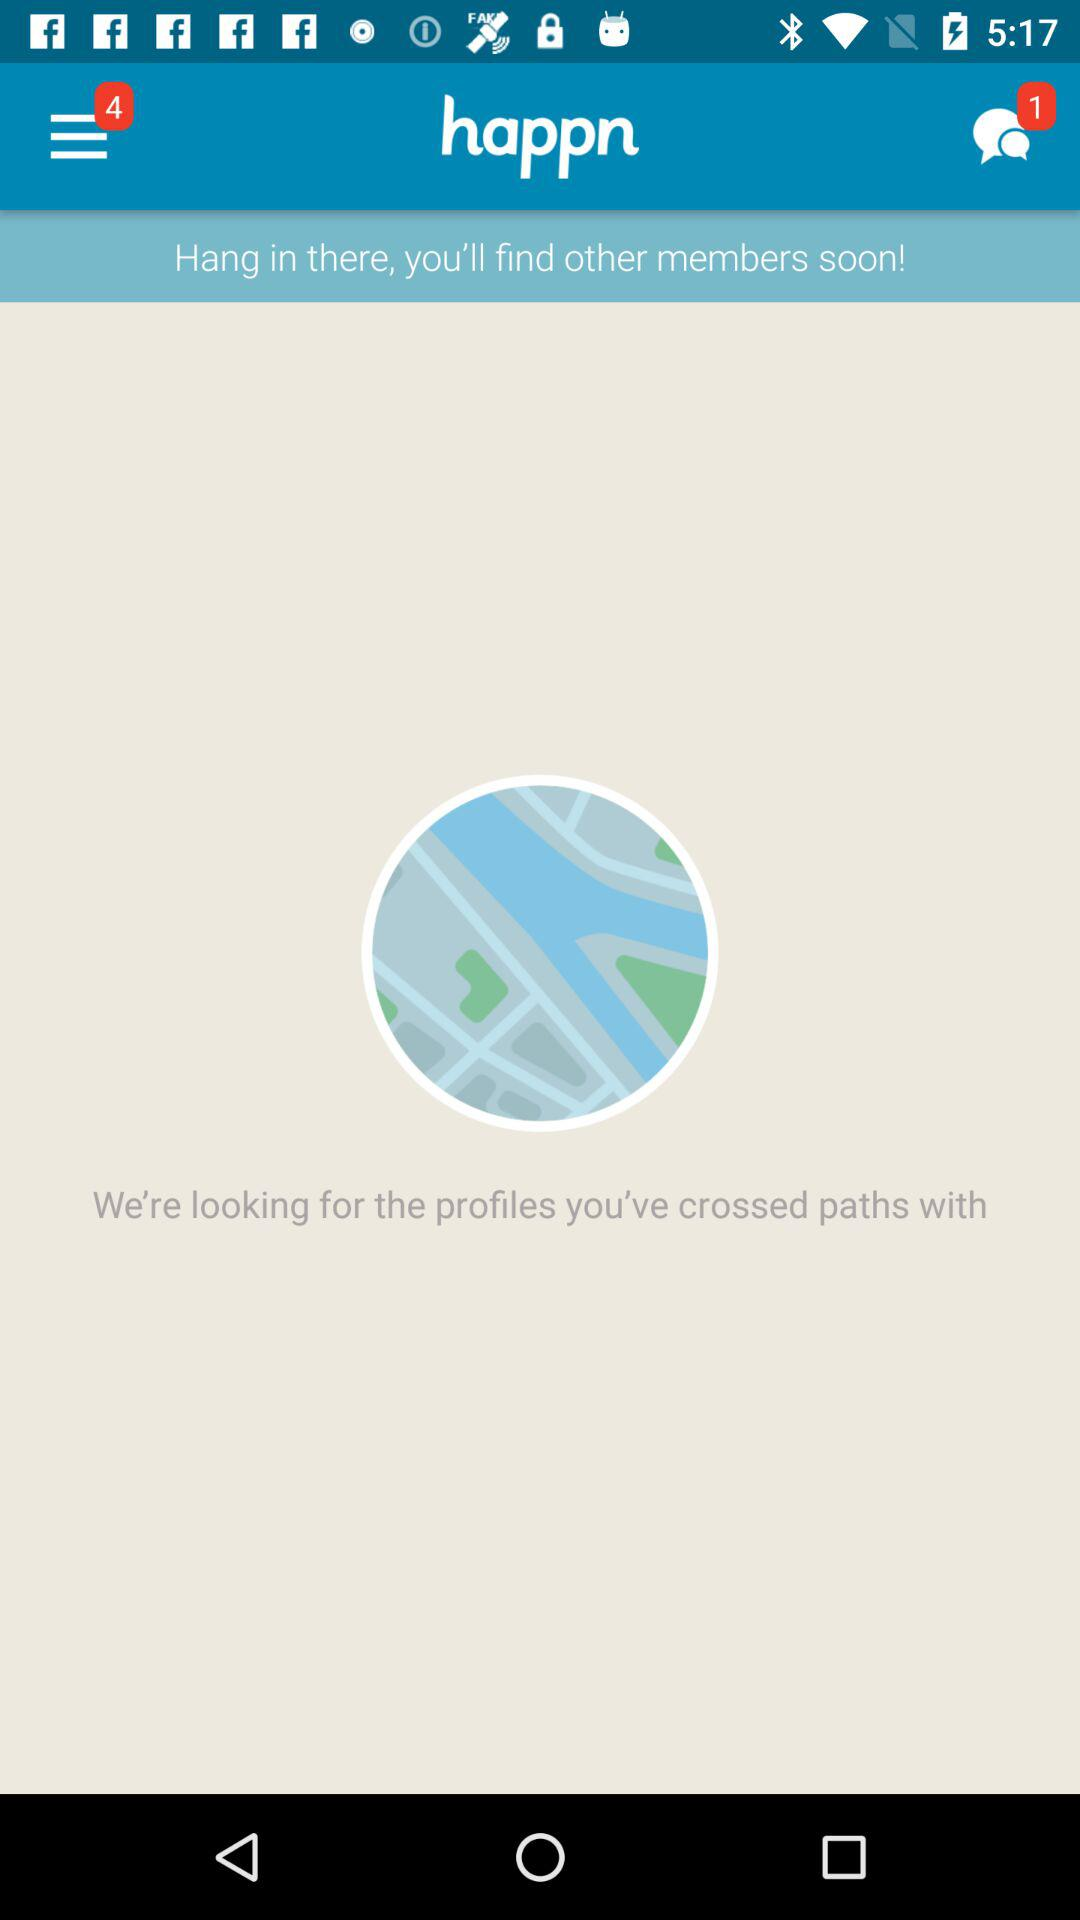What is the app name? The app name is "happn". 